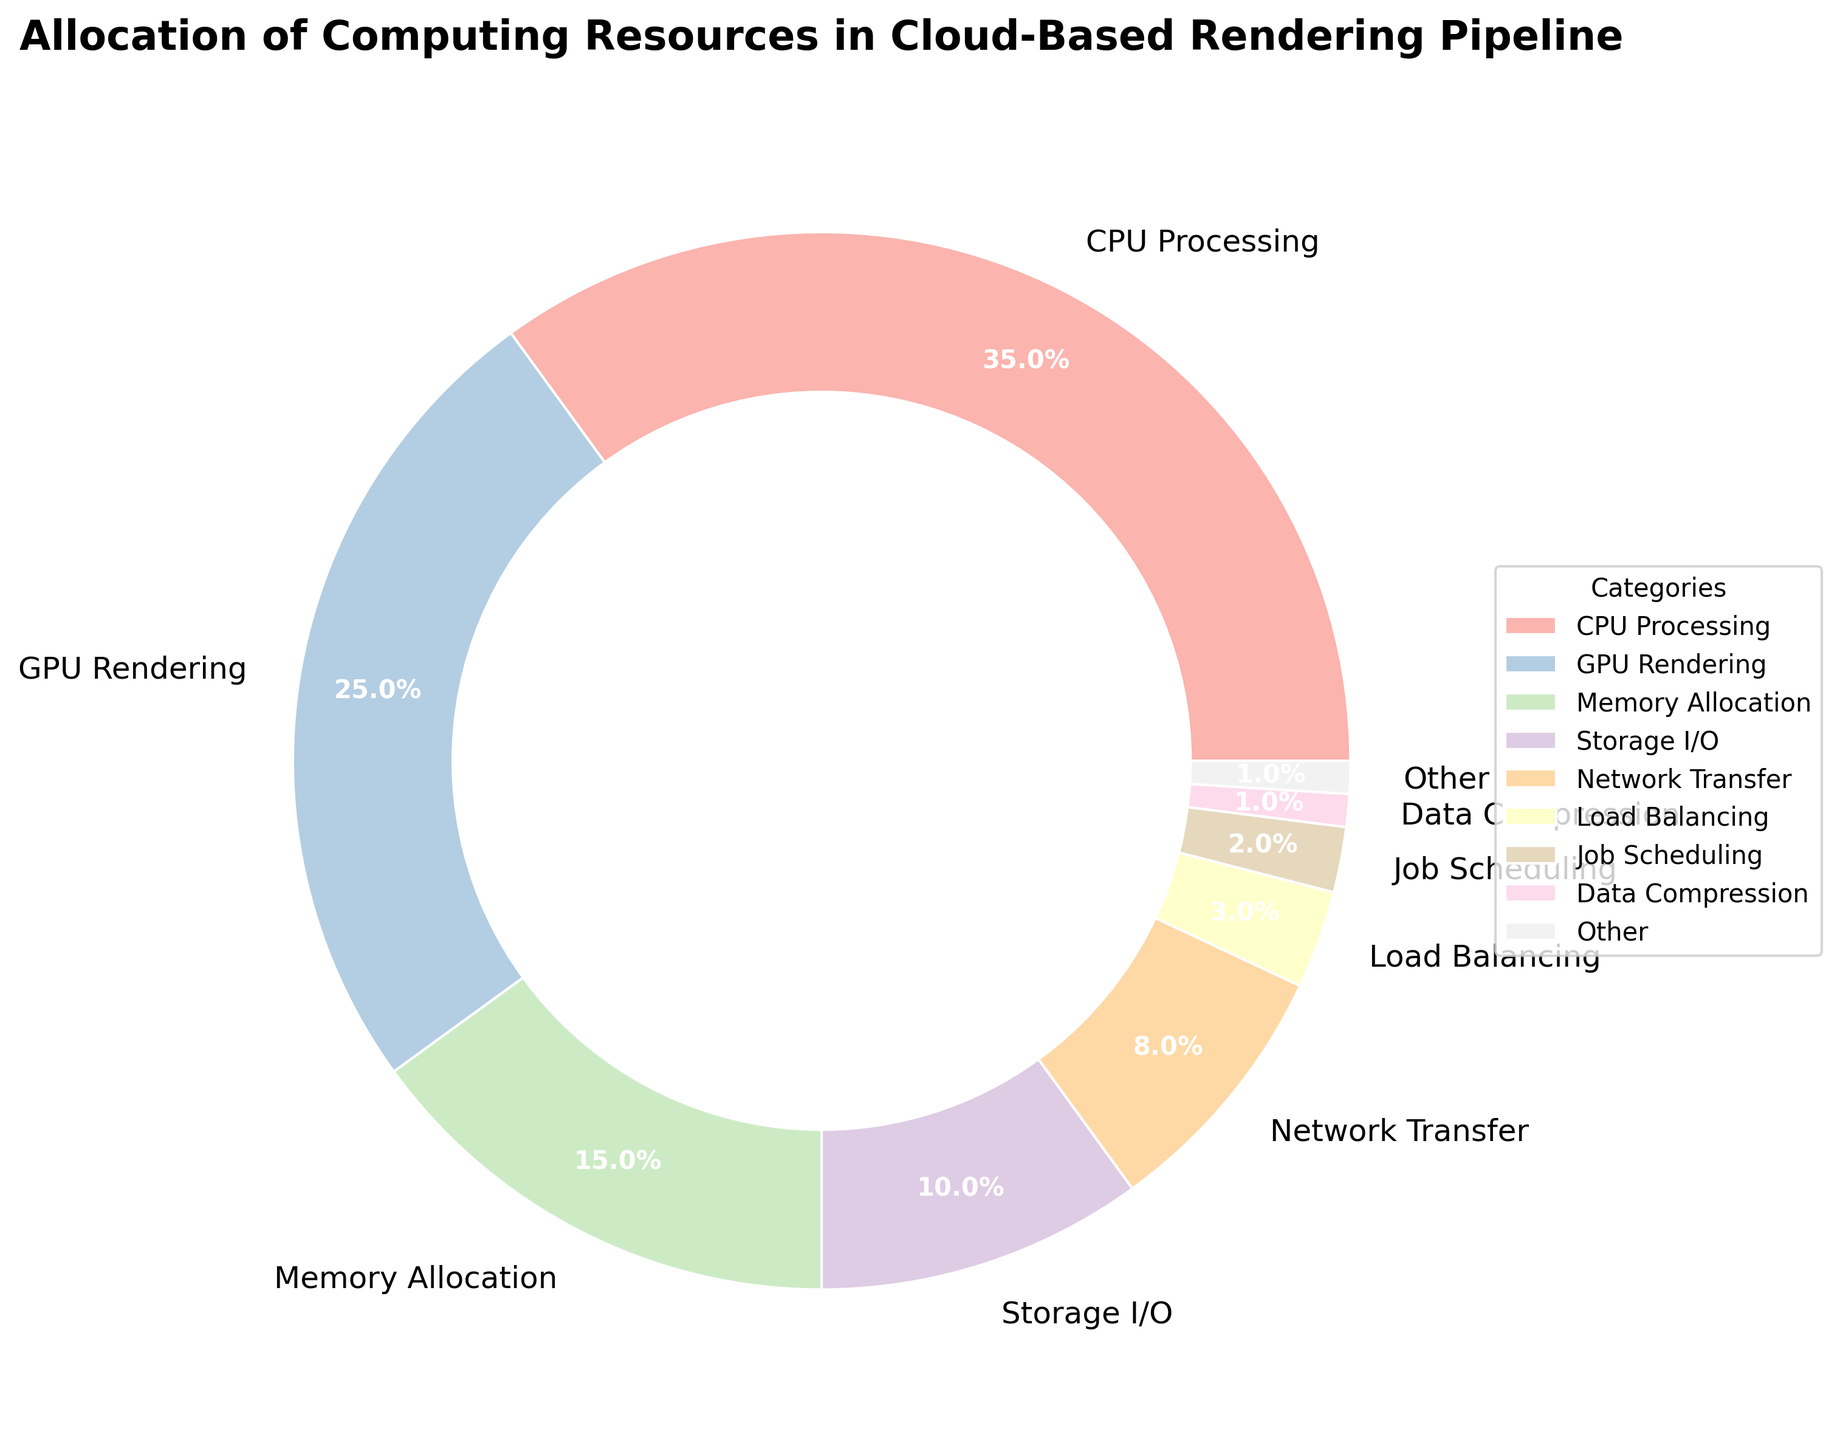What category allocates the largest percentage of computing resources? CPU Processing has the largest segment in the pie chart, labeled as 35%.
Answer: CPU Processing What is the total percentage allocated to GPU Rendering and Memory Allocation? The percentage for GPU Rendering is 25%, and for Memory Allocation, it is 15%. Adding these together, 25% + 15% = 40%.
Answer: 40% Which category has a higher allocation, Network Transfer or Storage I/O? Network Transfer is shown as 8%, while Storage I/O is shown as 10%. Since 8% < 10%, Storage I/O has a higher allocation.
Answer: Storage I/O How does the total percentage for categories with less than 1% compare to the category with the smallest percentage shown in the chart? The total category labeled as 'Other' accounts for the sum of percentages less than 1%, which includes Data Compression (1%), Caching (0.5%), Error Handling (0.3%), and Logging (0.2%). Summing up these gives: 1% + 0.5% + 0.3% + 0.2% = 2%. This 'Other' percentage is larger than the individual category with the smallest percentage shown in the chart (Job Scheduling, 2%).
Answer: Other is equal If you combine the percentages of the two smallest individual categories shown in the pie chart, what is their total? The two smallest individual categories are Job Scheduling (2%) and Load Balancing (3%). Adding these together, 2% + 3% = 5%.
Answer: 5% Which categories together make up a third of the total computing resource allocation? A third of the total (100%) is approximately 33.33%. CPU Processing (35%) by itself exceeds this threshold. No combination without CPU Processing reaches exactly a third. However, combining categories such as GPU Rendering (25%) and Memory Allocation (15%) achieves this with 25% + 15% = 40%, slightly more than a third.
Answer: CPU Processing What is the total percentage of computing resources not allocated to CPU Processing, GPU Rendering, and Memory Allocation? The total percentage of the three categories is 35% (CPU Processing) + 25% (GPU Rendering) + 15% (Memory Allocation) = 75%. The remaining percentage is 100% - 75% = 25%.
Answer: 25% How does the 'Other' category compare to Network Transfer in terms of percentage allocation? The 'Other' category is made up of percentages less than 1%, which sums to 1%. Network Transfer is labeled as 8%, so 1% < 8%. This indicates Network Transfer has a higher allocation.
Answer: Network Transfer is higher What is the ratio of CPU Processing allocation to GPU Rendering allocation? CPU Processing is 35%, and GPU Rendering is 25%. Dividing these, the ratio is 35/25 = 1.4.
Answer: 1.4 How many categories allocate more than 10% of computing resources? By referring to the pie chart, three categories allocate more than 10% of resources: CPU Processing (35%), GPU Rendering (25%), and Memory Allocation (15%).
Answer: Three categories 